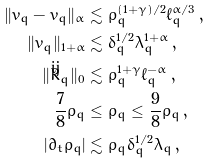Convert formula to latex. <formula><loc_0><loc_0><loc_500><loc_500>\| \bar { v } _ { q } - v _ { q } \| _ { \alpha } & \lesssim \bar { \rho } _ { q } ^ { ( 1 + \gamma ) / 2 } \ell _ { q } ^ { \alpha / 3 } \, , \\ \| \bar { v } _ { q } \| _ { 1 + \alpha } & \lesssim \delta _ { q } ^ { 1 / 2 } \lambda _ { q } ^ { 1 + \alpha } \, , \\ \| \mathring { \bar { R } } _ { q } \| _ { 0 } & \lesssim \bar { \rho } _ { q } ^ { 1 + { \gamma } } \ell _ { q } ^ { - \alpha } \, , \\ \frac { 7 } { 8 } \rho _ { q } & \leq \bar { \rho } _ { q } \leq \frac { 9 } { 8 } \rho _ { q } \, , \\ | \partial _ { t } \bar { \rho } _ { q } | & \lesssim \bar { \rho } _ { q } \delta _ { q } ^ { 1 / 2 } \lambda _ { q } \, ,</formula> 